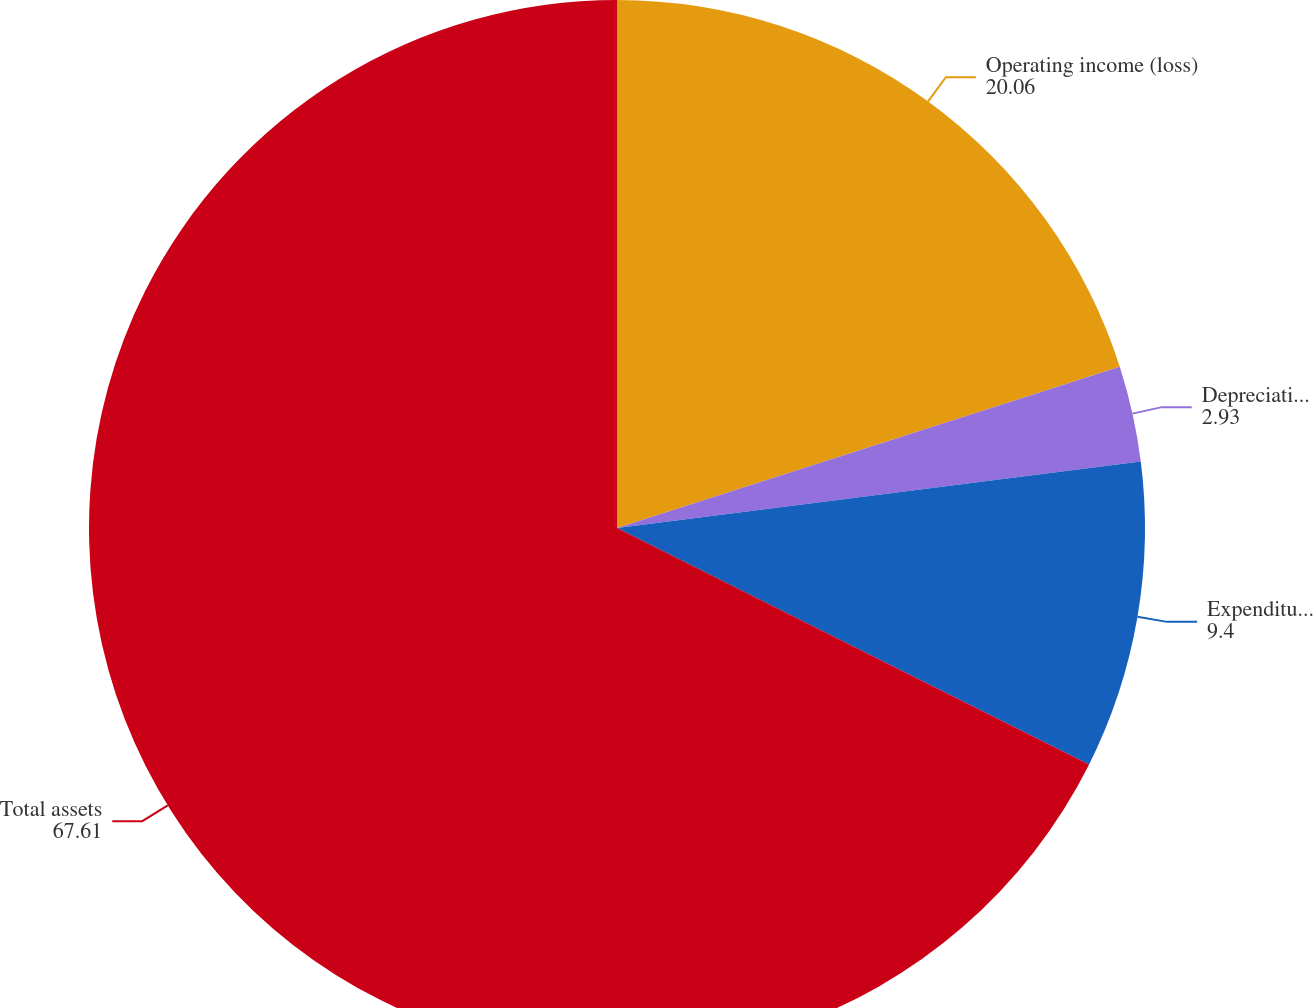<chart> <loc_0><loc_0><loc_500><loc_500><pie_chart><fcel>Operating income (loss)<fcel>Depreciation and amortization<fcel>Expenditures for long-lived<fcel>Total assets<nl><fcel>20.06%<fcel>2.93%<fcel>9.4%<fcel>67.61%<nl></chart> 